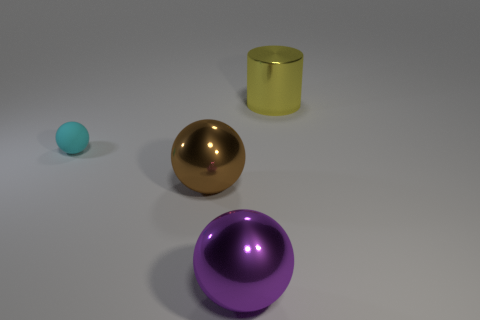How many other things are there of the same color as the big cylinder?
Your answer should be very brief. 0. Is the number of purple balls less than the number of blue cubes?
Give a very brief answer. No. The metallic thing that is to the right of the large metallic object that is in front of the brown metallic sphere is what shape?
Provide a succinct answer. Cylinder. Are there any cyan matte balls in front of the yellow metallic cylinder?
Make the answer very short. Yes. What color is the metallic ball that is the same size as the purple object?
Offer a very short reply. Brown. How many cyan balls have the same material as the purple sphere?
Make the answer very short. 0. What number of other things are the same size as the purple metal object?
Your response must be concise. 2. Are there any other yellow shiny cylinders that have the same size as the metallic cylinder?
Make the answer very short. No. Do the shiny sphere left of the purple ball and the small rubber thing have the same color?
Your response must be concise. No. What number of things are matte objects or large purple spheres?
Your answer should be very brief. 2. 